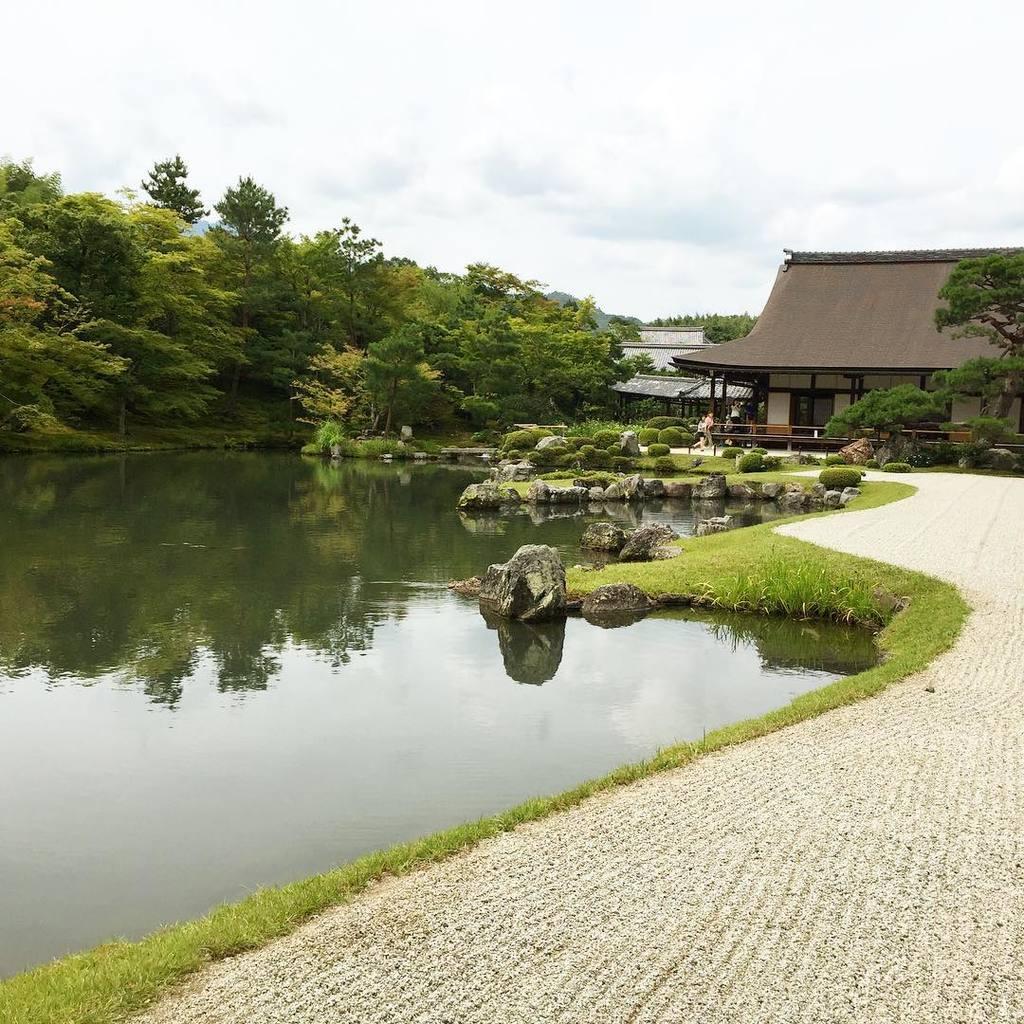In one or two sentences, can you explain what this image depicts? In this image on the left side we can see water and on the right side we can see the path and grass on the ground. In the background there are stones, trees, few persons, houses, roofs, fences and clouds in the sky. 